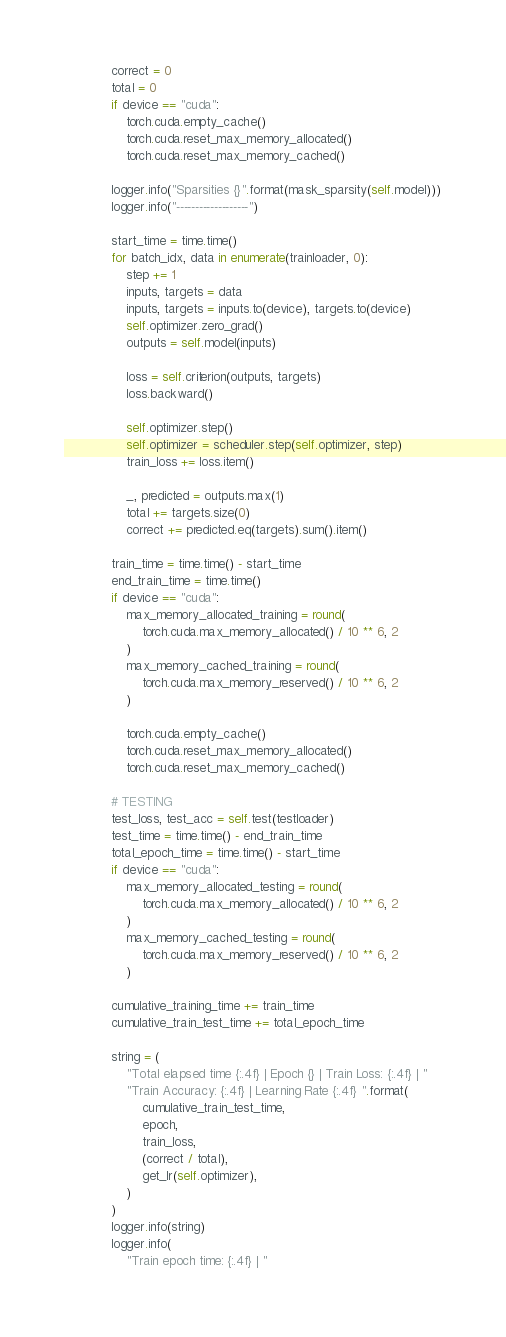<code> <loc_0><loc_0><loc_500><loc_500><_Python_>            correct = 0
            total = 0
            if device == "cuda":
                torch.cuda.empty_cache()
                torch.cuda.reset_max_memory_allocated()
                torch.cuda.reset_max_memory_cached()

            logger.info("Sparsities {}".format(mask_sparsity(self.model)))
            logger.info("-------------------")

            start_time = time.time()
            for batch_idx, data in enumerate(trainloader, 0):
                step += 1
                inputs, targets = data
                inputs, targets = inputs.to(device), targets.to(device)
                self.optimizer.zero_grad()
                outputs = self.model(inputs)

                loss = self.criterion(outputs, targets)
                loss.backward()

                self.optimizer.step()
                self.optimizer = scheduler.step(self.optimizer, step)
                train_loss += loss.item()

                _, predicted = outputs.max(1)
                total += targets.size(0)
                correct += predicted.eq(targets).sum().item()

            train_time = time.time() - start_time
            end_train_time = time.time()
            if device == "cuda":
                max_memory_allocated_training = round(
                    torch.cuda.max_memory_allocated() / 10 ** 6, 2
                )
                max_memory_cached_training = round(
                    torch.cuda.max_memory_reserved() / 10 ** 6, 2
                )

                torch.cuda.empty_cache()
                torch.cuda.reset_max_memory_allocated()
                torch.cuda.reset_max_memory_cached()

            # TESTING
            test_loss, test_acc = self.test(testloader)
            test_time = time.time() - end_train_time
            total_epoch_time = time.time() - start_time
            if device == "cuda":
                max_memory_allocated_testing = round(
                    torch.cuda.max_memory_allocated() / 10 ** 6, 2
                )
                max_memory_cached_testing = round(
                    torch.cuda.max_memory_reserved() / 10 ** 6, 2
                )

            cumulative_training_time += train_time
            cumulative_train_test_time += total_epoch_time

            string = (
                "Total elapsed time {:.4f} | Epoch {} | Train Loss: {:.4f} | "
                "Train Accuracy: {:.4f} | Learning Rate {:.4f} ".format(
                    cumulative_train_test_time,
                    epoch,
                    train_loss,
                    (correct / total),
                    get_lr(self.optimizer),
                )
            )
            logger.info(string)
            logger.info(
                "Train epoch time: {:.4f} | "</code> 